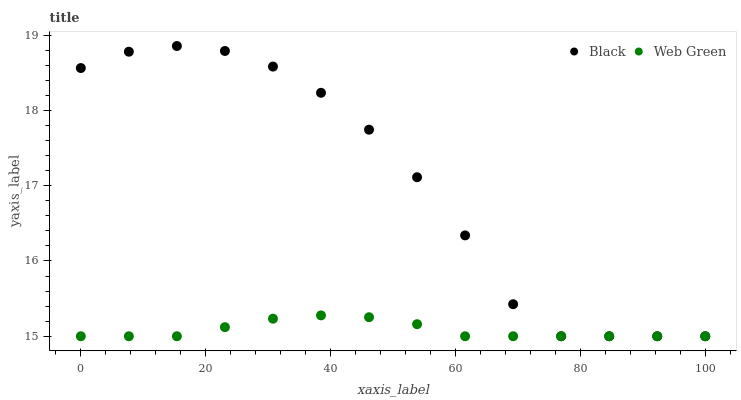Does Web Green have the minimum area under the curve?
Answer yes or no. Yes. Does Black have the maximum area under the curve?
Answer yes or no. Yes. Does Web Green have the maximum area under the curve?
Answer yes or no. No. Is Web Green the smoothest?
Answer yes or no. Yes. Is Black the roughest?
Answer yes or no. Yes. Is Web Green the roughest?
Answer yes or no. No. Does Black have the lowest value?
Answer yes or no. Yes. Does Black have the highest value?
Answer yes or no. Yes. Does Web Green have the highest value?
Answer yes or no. No. Does Web Green intersect Black?
Answer yes or no. Yes. Is Web Green less than Black?
Answer yes or no. No. Is Web Green greater than Black?
Answer yes or no. No. 